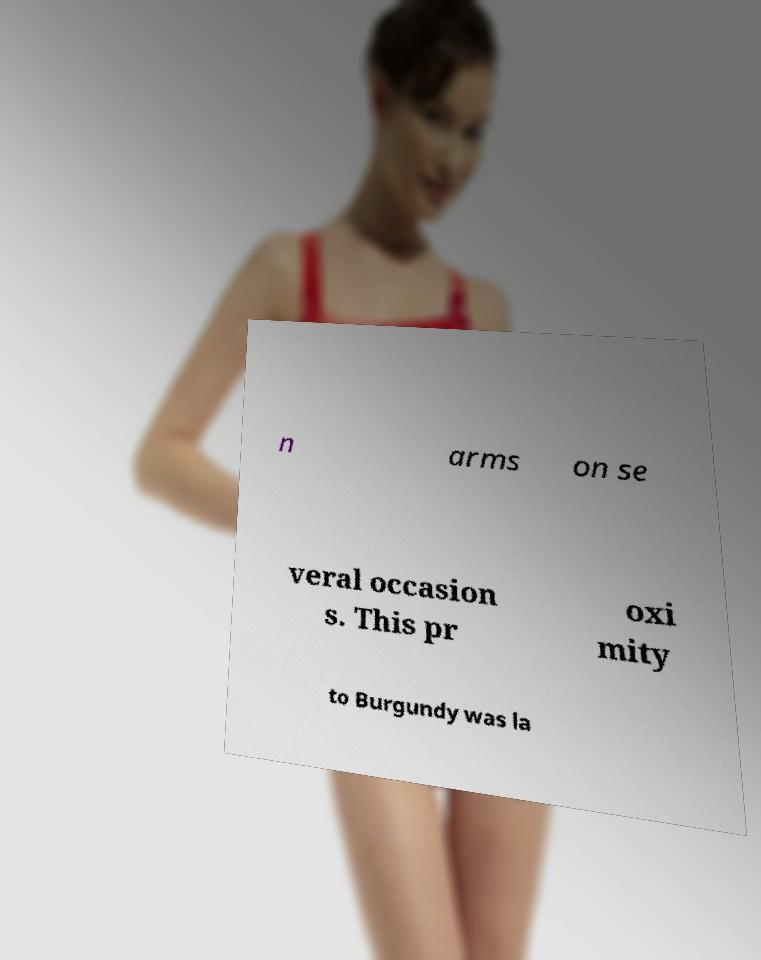For documentation purposes, I need the text within this image transcribed. Could you provide that? n arms on se veral occasion s. This pr oxi mity to Burgundy was la 